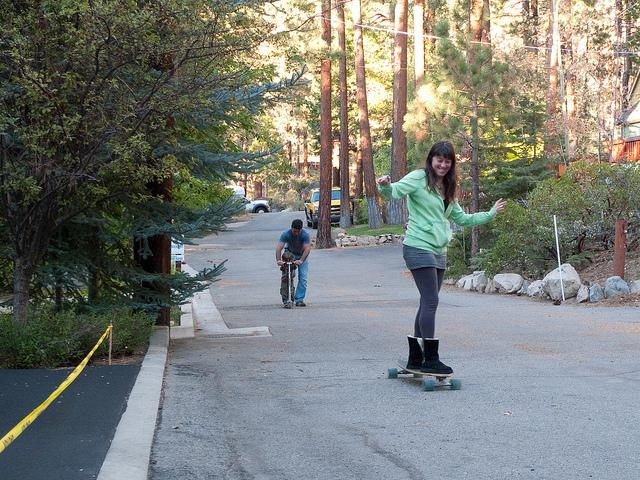What is the Man teaching the child? Please explain your reasoning. scooter riding. He has his hands on the handlebars. 